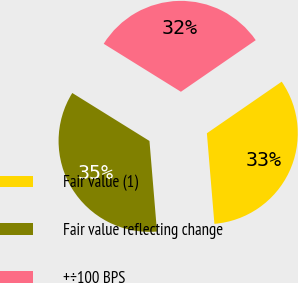Convert chart to OTSL. <chart><loc_0><loc_0><loc_500><loc_500><pie_chart><fcel>Fair value (1)<fcel>Fair value reflecting change<fcel>+÷100 BPS<nl><fcel>33.29%<fcel>35.17%<fcel>31.54%<nl></chart> 